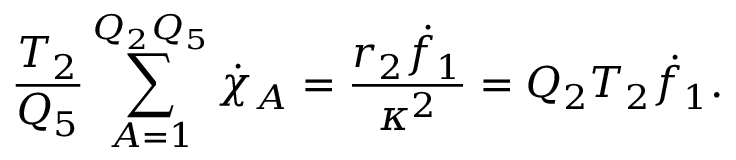<formula> <loc_0><loc_0><loc_500><loc_500>{ \frac { T _ { 2 } } { Q _ { 5 } } } \sum _ { A = 1 } ^ { Q _ { 2 } Q _ { 5 } } \dot { \chi } _ { A } = { \frac { r _ { 2 } { \dot { f } _ { 1 } } } { \kappa ^ { 2 } } } = Q _ { 2 } T _ { 2 } \dot { f } _ { 1 } .</formula> 